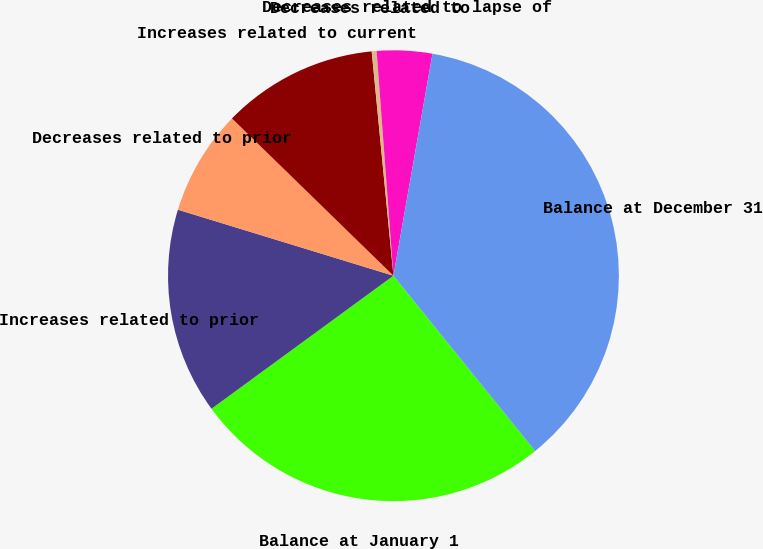<chart> <loc_0><loc_0><loc_500><loc_500><pie_chart><fcel>Balance at January 1<fcel>Increases related to prior<fcel>Decreases related to prior<fcel>Increases related to current<fcel>Decreases related to<fcel>Decreases related to lapse of<fcel>Balance at December 31<nl><fcel>25.77%<fcel>14.78%<fcel>7.56%<fcel>11.17%<fcel>0.35%<fcel>3.96%<fcel>36.41%<nl></chart> 